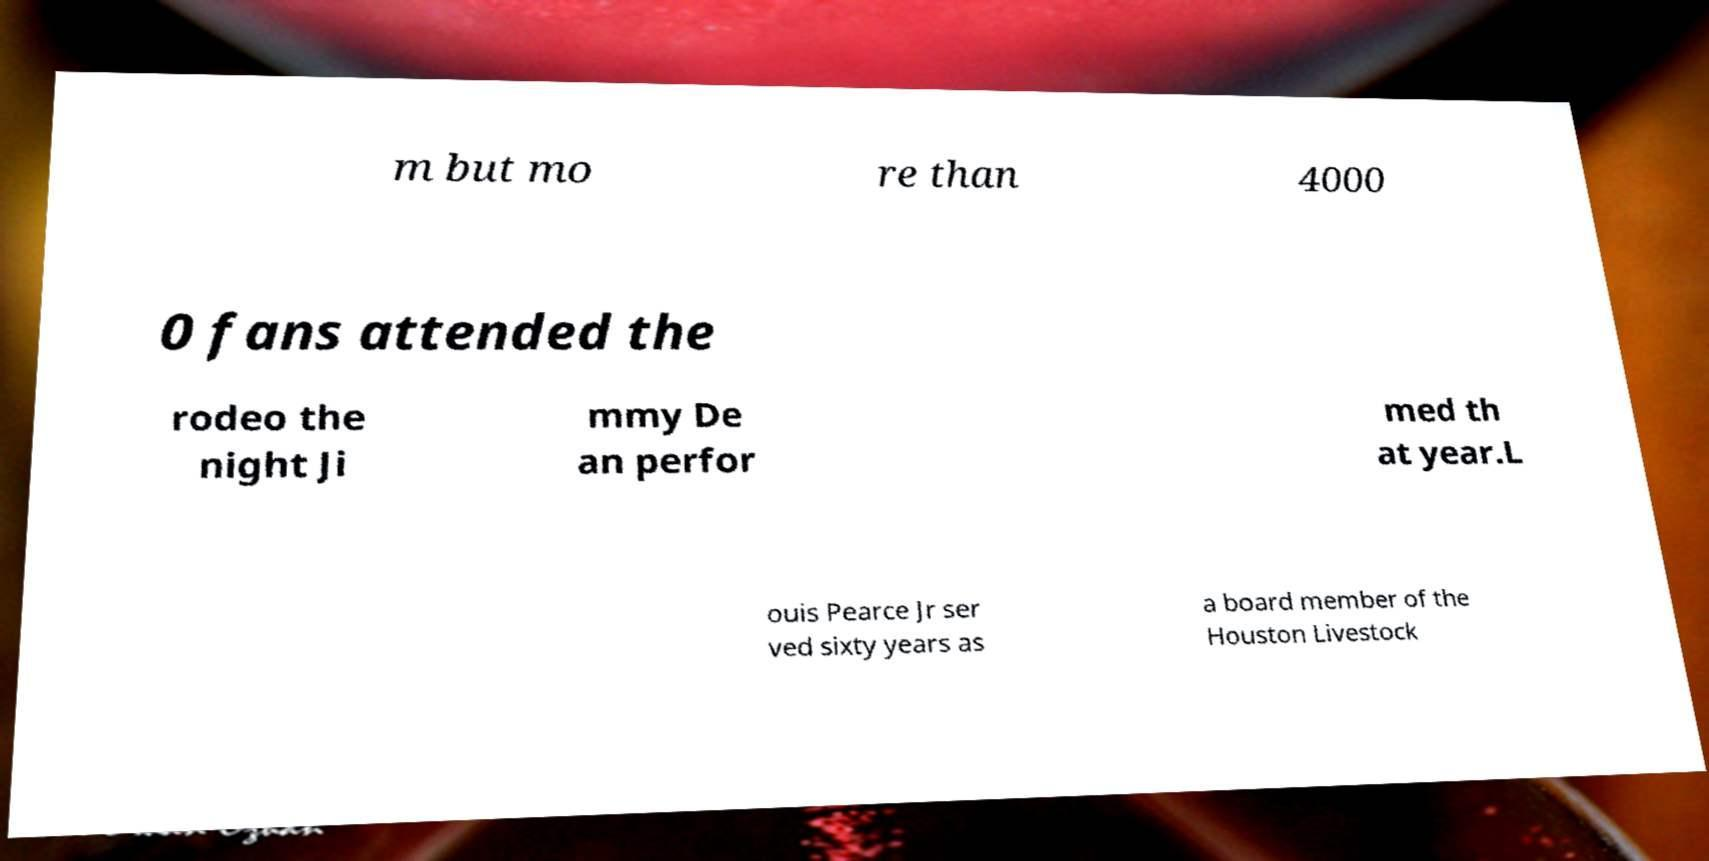Please identify and transcribe the text found in this image. m but mo re than 4000 0 fans attended the rodeo the night Ji mmy De an perfor med th at year.L ouis Pearce Jr ser ved sixty years as a board member of the Houston Livestock 